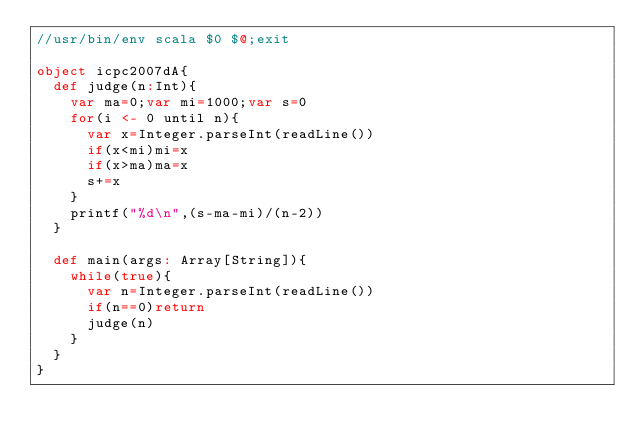Convert code to text. <code><loc_0><loc_0><loc_500><loc_500><_Scala_>//usr/bin/env scala $0 $@;exit

object icpc2007dA{
	def judge(n:Int){
		var ma=0;var mi=1000;var s=0
		for(i <- 0 until n){
			var x=Integer.parseInt(readLine())
			if(x<mi)mi=x
			if(x>ma)ma=x
			s+=x
		}
		printf("%d\n",(s-ma-mi)/(n-2))
	}

	def main(args: Array[String]){
		while(true){
			var n=Integer.parseInt(readLine())
			if(n==0)return
			judge(n)
		}
	}
}</code> 